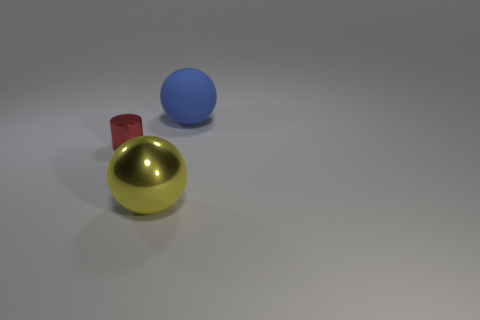Add 1 tiny red cylinders. How many objects exist? 4 Subtract all cylinders. How many objects are left? 2 Subtract all spheres. Subtract all matte objects. How many objects are left? 0 Add 2 big yellow things. How many big yellow things are left? 3 Add 1 big blue metallic spheres. How many big blue metallic spheres exist? 1 Subtract 0 cyan cylinders. How many objects are left? 3 